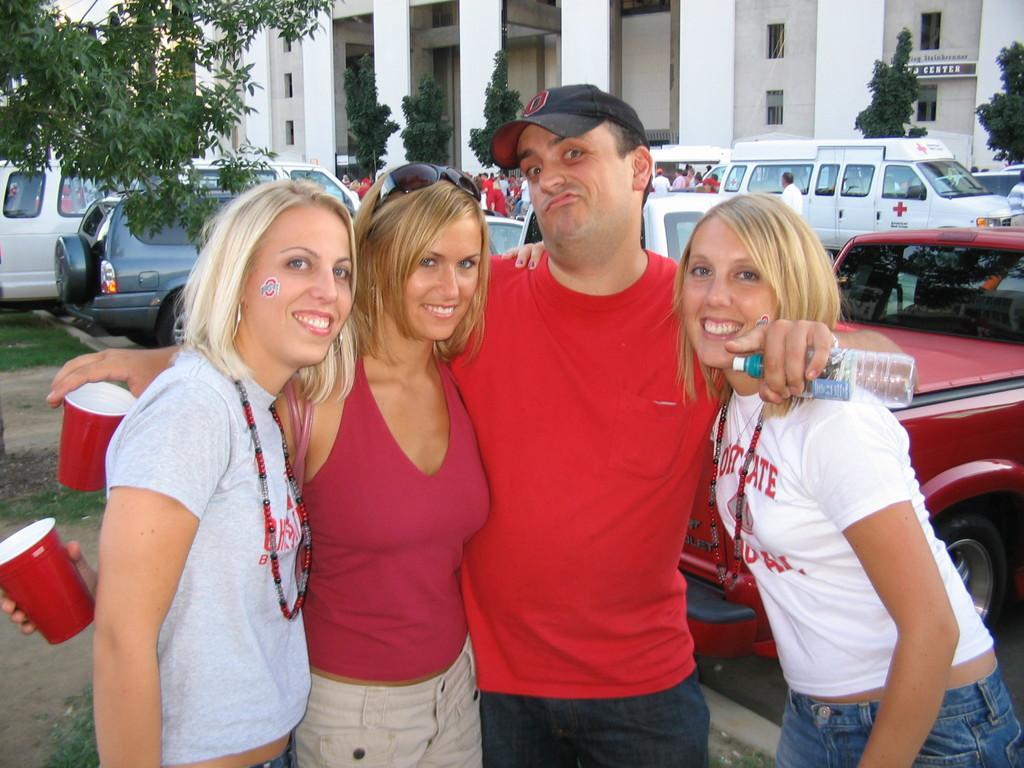How would you summarize this image in a sentence or two? In this image we can see a group of people standing on the ground holding a bottle and glasses. On the backside we can see some cars, vehicles, grass, trees and a building with windows, pillars and a name board. 